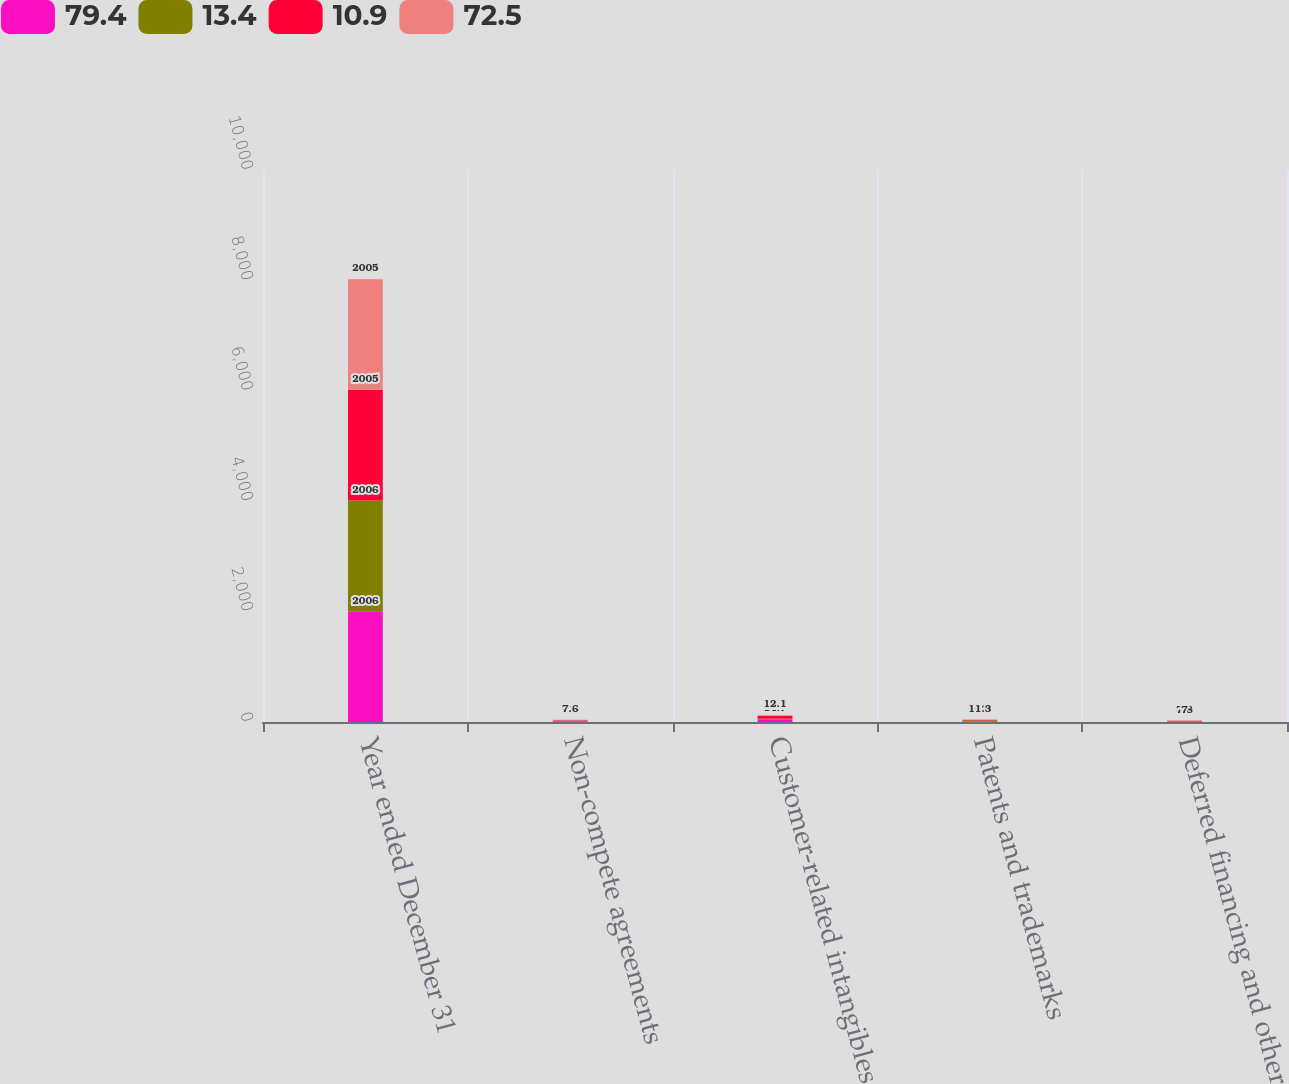Convert chart. <chart><loc_0><loc_0><loc_500><loc_500><stacked_bar_chart><ecel><fcel>Year ended December 31<fcel>Non-compete agreements<fcel>Customer-related intangibles<fcel>Patents and trademarks<fcel>Deferred financing and other<nl><fcel>79.4<fcel>2006<fcel>15<fcel>45<fcel>6.1<fcel>6.4<nl><fcel>13.4<fcel>2006<fcel>9<fcel>14.7<fcel>20.1<fcel>7.2<nl><fcel>10.9<fcel>2005<fcel>9.6<fcel>52.7<fcel>9.3<fcel>7.8<nl><fcel>72.5<fcel>2005<fcel>7.6<fcel>12.1<fcel>11.3<fcel>7<nl></chart> 